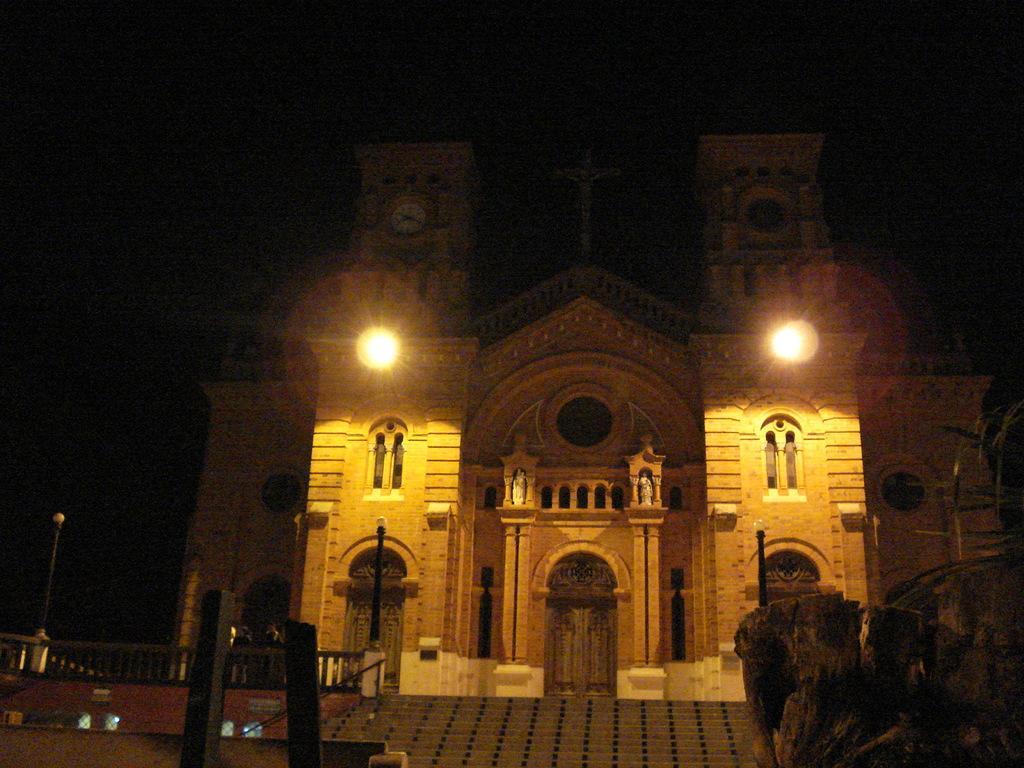Describe this image in one or two sentences. In this picture I can see a building, there are lights, poles, stairs. 